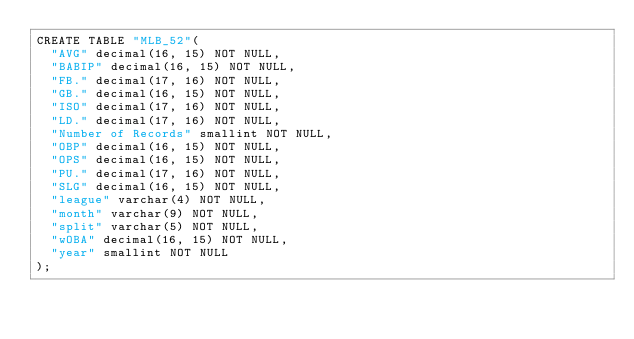<code> <loc_0><loc_0><loc_500><loc_500><_SQL_>CREATE TABLE "MLB_52"(
  "AVG" decimal(16, 15) NOT NULL,
  "BABIP" decimal(16, 15) NOT NULL,
  "FB." decimal(17, 16) NOT NULL,
  "GB." decimal(16, 15) NOT NULL,
  "ISO" decimal(17, 16) NOT NULL,
  "LD." decimal(17, 16) NOT NULL,
  "Number of Records" smallint NOT NULL,
  "OBP" decimal(16, 15) NOT NULL,
  "OPS" decimal(16, 15) NOT NULL,
  "PU." decimal(17, 16) NOT NULL,
  "SLG" decimal(16, 15) NOT NULL,
  "league" varchar(4) NOT NULL,
  "month" varchar(9) NOT NULL,
  "split" varchar(5) NOT NULL,
  "wOBA" decimal(16, 15) NOT NULL,
  "year" smallint NOT NULL
);
</code> 